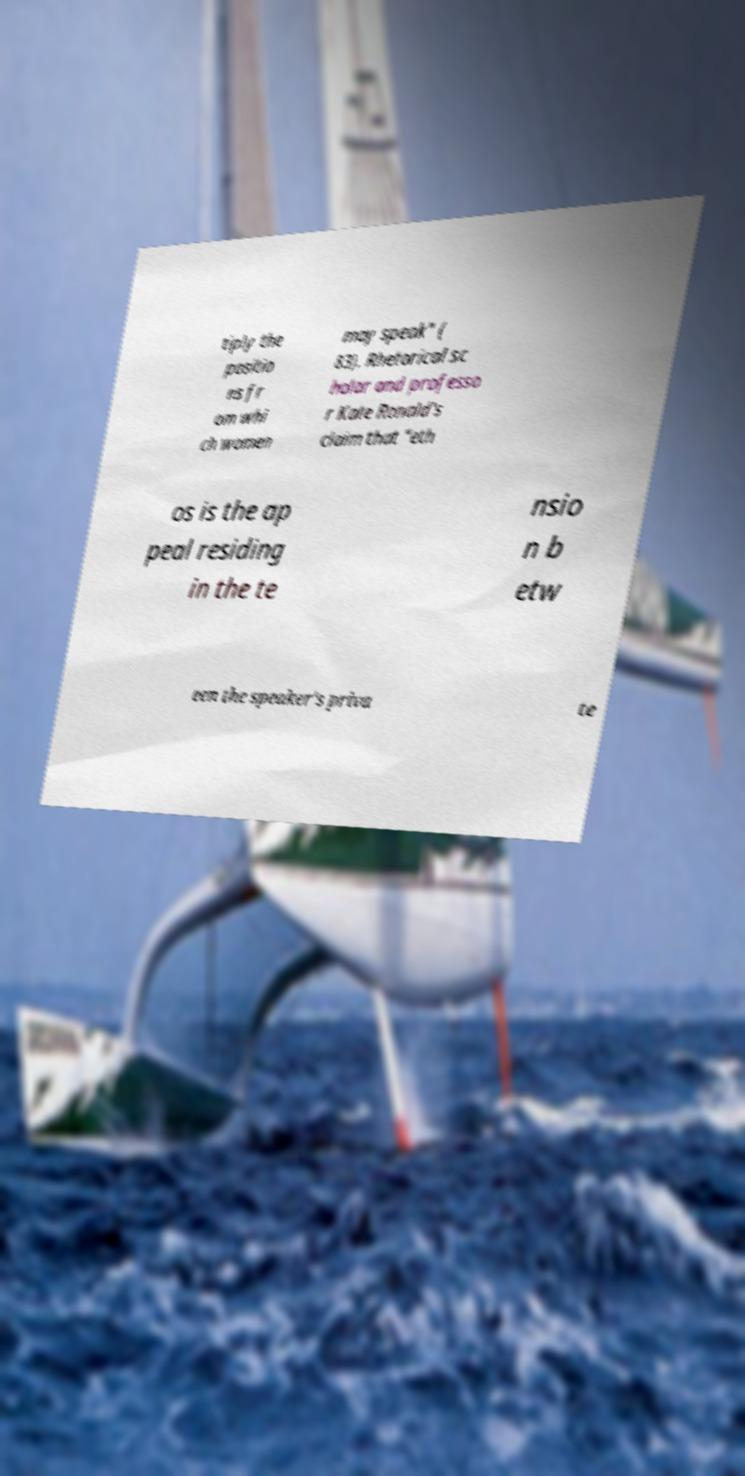Could you assist in decoding the text presented in this image and type it out clearly? tiply the positio ns fr om whi ch women may speak" ( 83). Rhetorical sc holar and professo r Kate Ronald's claim that "eth os is the ap peal residing in the te nsio n b etw een the speaker's priva te 